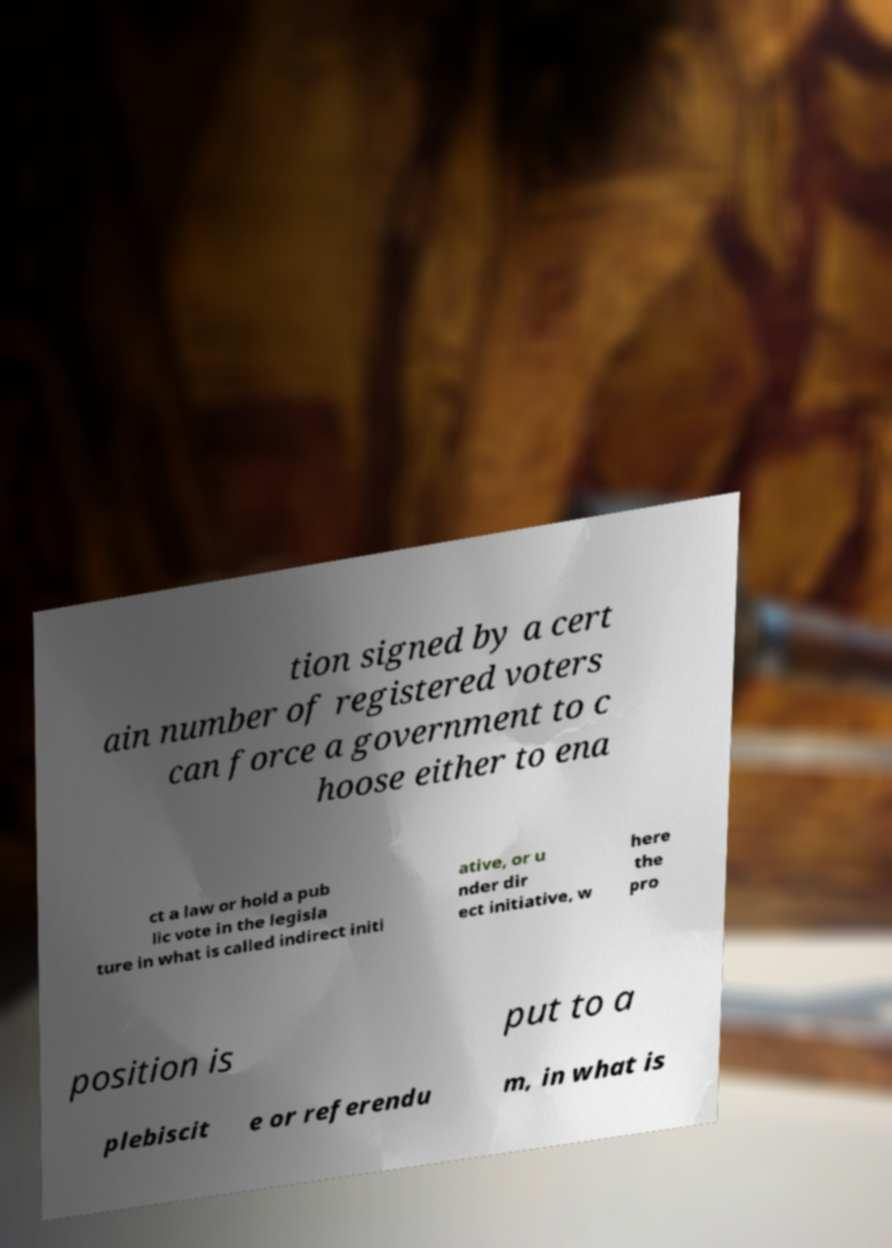I need the written content from this picture converted into text. Can you do that? tion signed by a cert ain number of registered voters can force a government to c hoose either to ena ct a law or hold a pub lic vote in the legisla ture in what is called indirect initi ative, or u nder dir ect initiative, w here the pro position is put to a plebiscit e or referendu m, in what is 